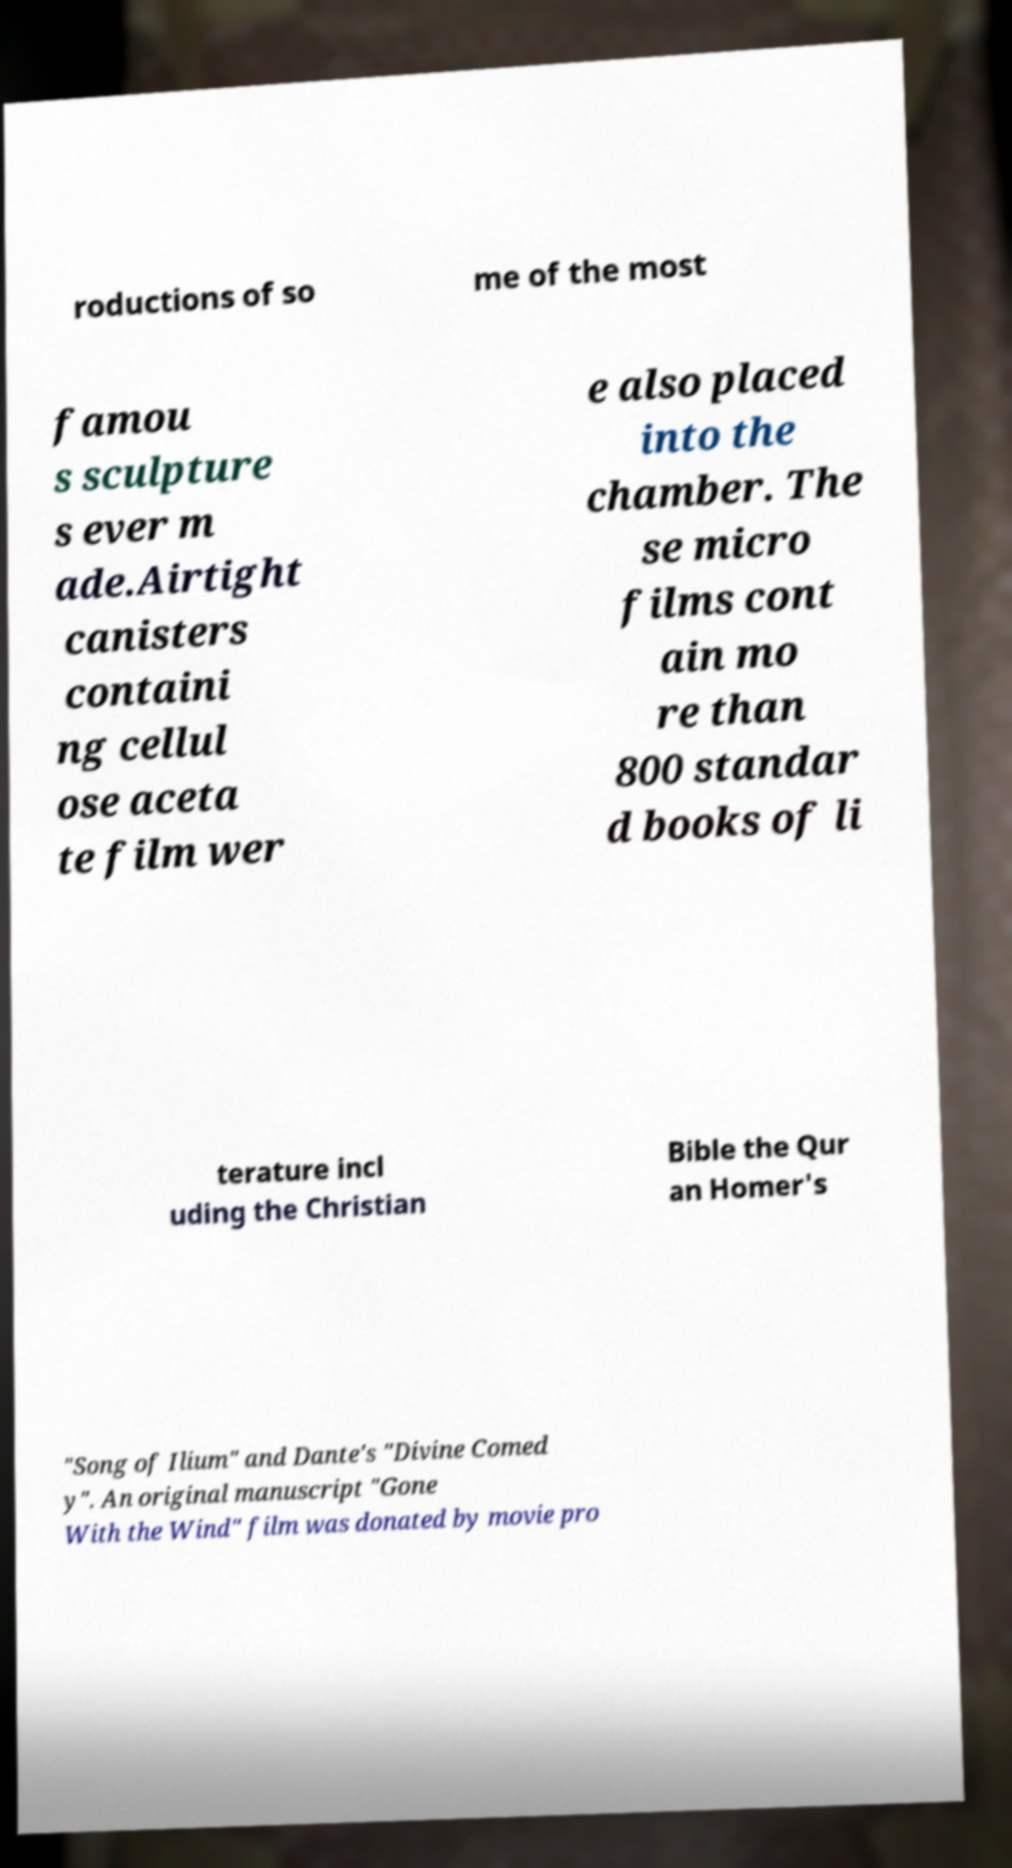Please identify and transcribe the text found in this image. roductions of so me of the most famou s sculpture s ever m ade.Airtight canisters containi ng cellul ose aceta te film wer e also placed into the chamber. The se micro films cont ain mo re than 800 standar d books of li terature incl uding the Christian Bible the Qur an Homer's "Song of Ilium" and Dante's "Divine Comed y". An original manuscript "Gone With the Wind" film was donated by movie pro 